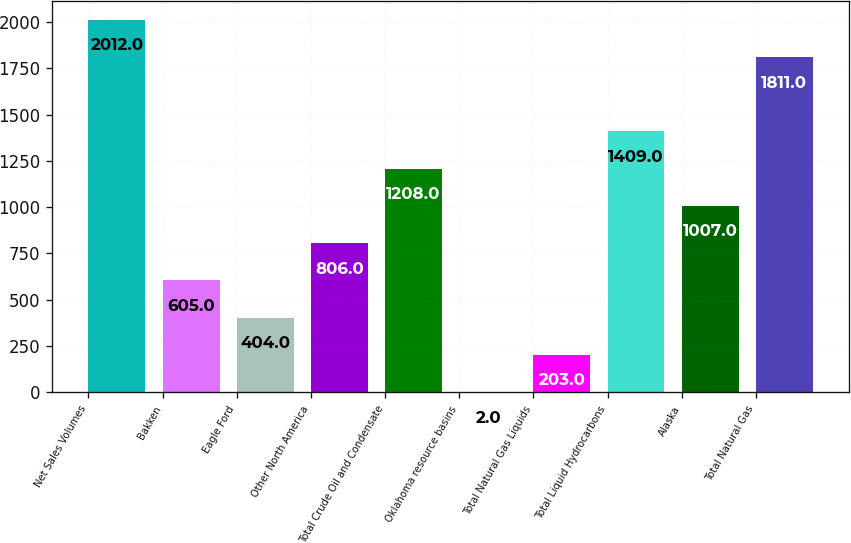Convert chart. <chart><loc_0><loc_0><loc_500><loc_500><bar_chart><fcel>Net Sales Volumes<fcel>Bakken<fcel>Eagle Ford<fcel>Other North America<fcel>Total Crude Oil and Condensate<fcel>Oklahoma resource basins<fcel>Total Natural Gas Liquids<fcel>Total Liquid Hydrocarbons<fcel>Alaska<fcel>Total Natural Gas<nl><fcel>2012<fcel>605<fcel>404<fcel>806<fcel>1208<fcel>2<fcel>203<fcel>1409<fcel>1007<fcel>1811<nl></chart> 